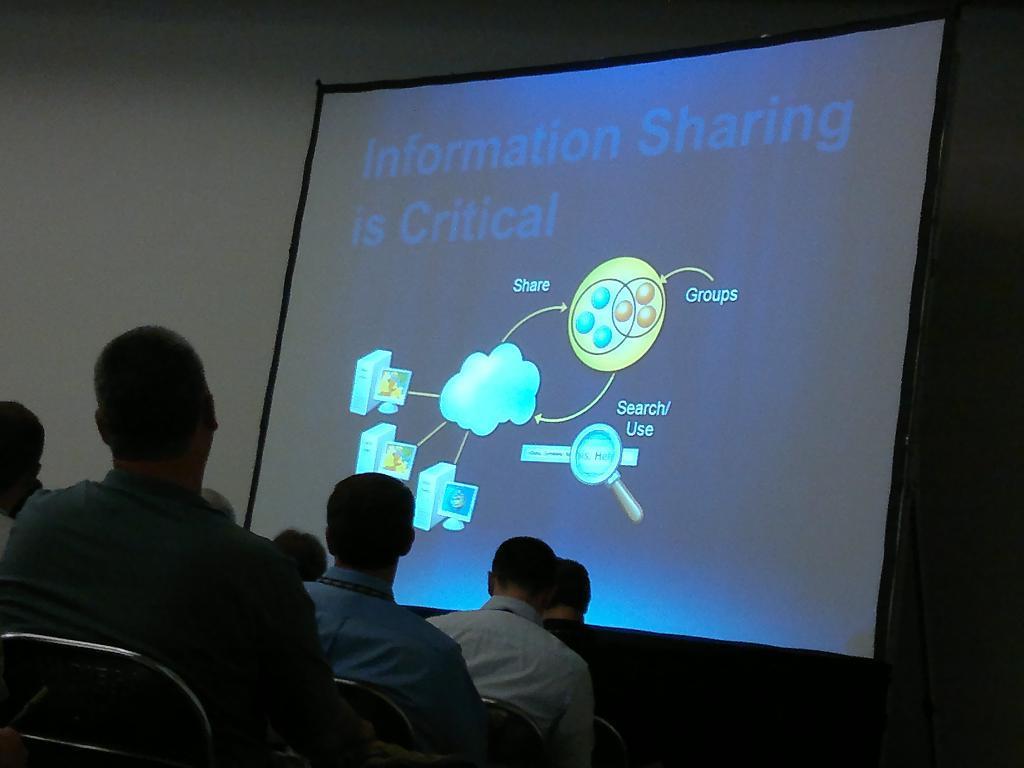In one or two sentences, can you explain what this image depicts? This image consists of many people sitting in the chairs. In the front, there is a projector screen. To the left, there is a wall. 